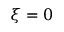Convert formula to latex. <formula><loc_0><loc_0><loc_500><loc_500>\xi = 0</formula> 